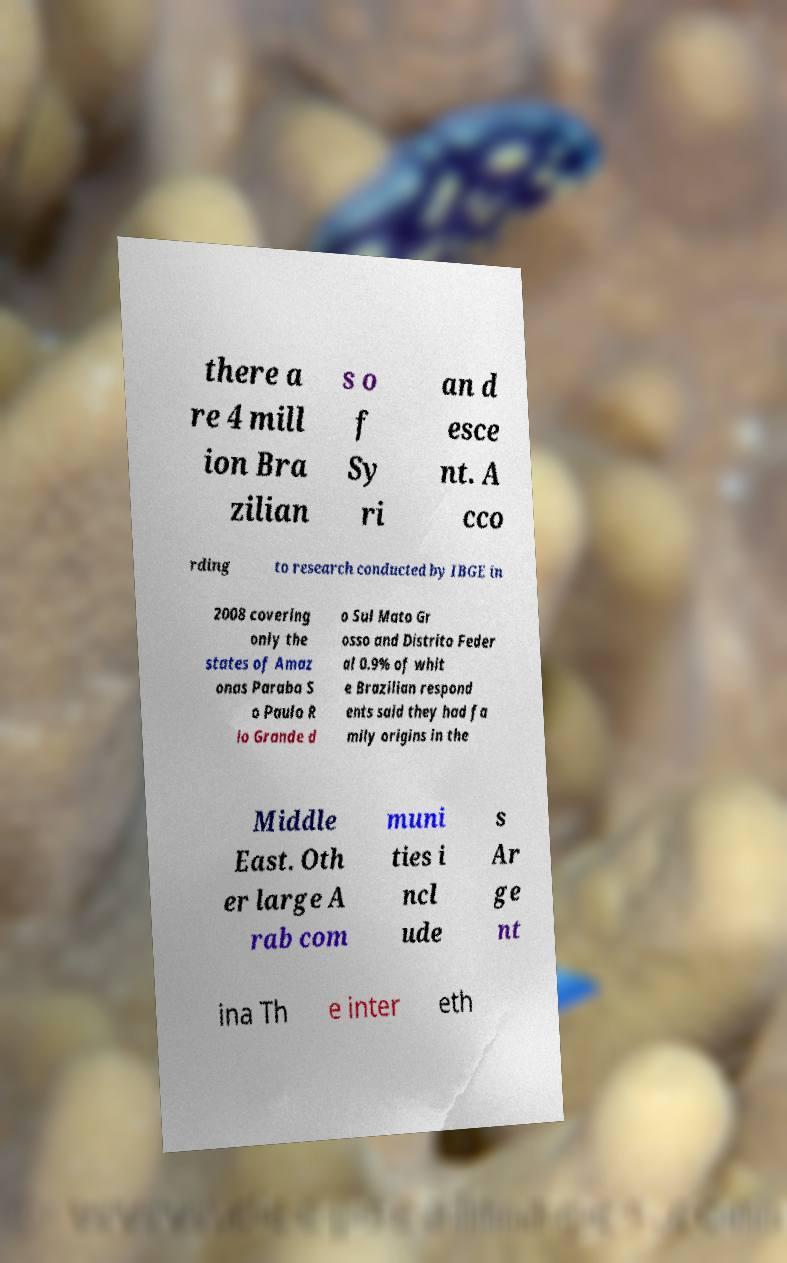I need the written content from this picture converted into text. Can you do that? there a re 4 mill ion Bra zilian s o f Sy ri an d esce nt. A cco rding to research conducted by IBGE in 2008 covering only the states of Amaz onas Paraba S o Paulo R io Grande d o Sul Mato Gr osso and Distrito Feder al 0.9% of whit e Brazilian respond ents said they had fa mily origins in the Middle East. Oth er large A rab com muni ties i ncl ude s Ar ge nt ina Th e inter eth 